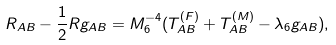<formula> <loc_0><loc_0><loc_500><loc_500>R _ { A B } - \frac { 1 } { 2 } R g _ { A B } = M _ { 6 } ^ { - 4 } ( T _ { A B } ^ { ( F ) } + T _ { A B } ^ { ( M ) } - \lambda _ { 6 } g _ { A B } ) ,</formula> 